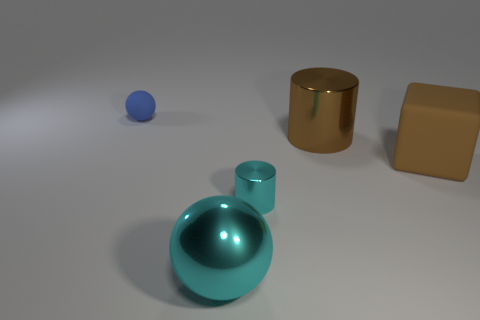There is a metal cylinder that is right of the tiny metal object; how many small metal cylinders are in front of it?
Offer a terse response. 1. Are there fewer large cylinders to the right of the small blue rubber thing than things left of the large cylinder?
Your response must be concise. Yes. There is a matte object to the left of the large brown object in front of the large brown shiny cylinder; what is its shape?
Provide a succinct answer. Sphere. What number of other objects are the same material as the large cyan sphere?
Ensure brevity in your answer.  2. Are there more tiny blue objects than matte objects?
Provide a succinct answer. No. There is a metallic thing that is in front of the cyan object that is behind the metallic thing in front of the cyan cylinder; how big is it?
Ensure brevity in your answer.  Large. Does the cyan cylinder have the same size as the cylinder that is behind the big cube?
Offer a terse response. No. Are there fewer tiny balls behind the brown matte block than large objects?
Your answer should be compact. Yes. What number of big balls are the same color as the large block?
Your response must be concise. 0. Is the number of tiny blue rubber things less than the number of small brown metal cylinders?
Make the answer very short. No. 